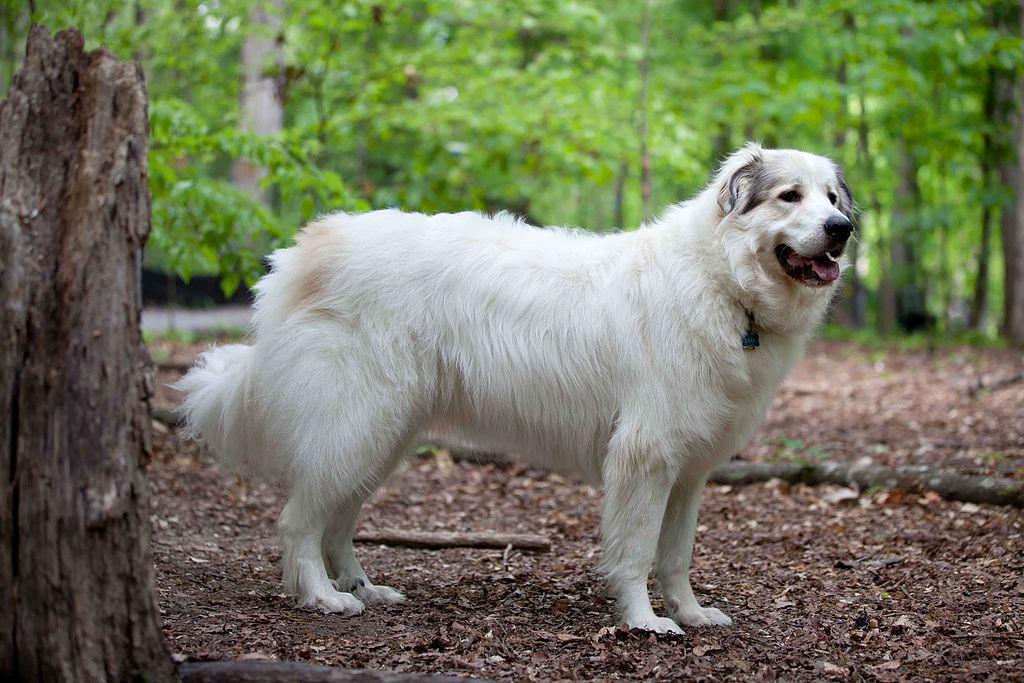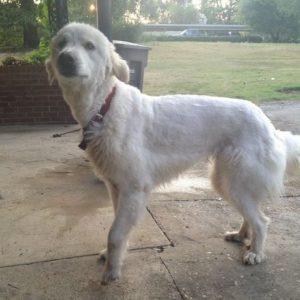The first image is the image on the left, the second image is the image on the right. For the images displayed, is the sentence "One dog has its mouth open." factually correct? Answer yes or no. Yes. The first image is the image on the left, the second image is the image on the right. Analyze the images presented: Is the assertion "Each image contains no more than one white dog, the dog in the right image is outdoors, and at least one dog wears a collar." valid? Answer yes or no. Yes. 